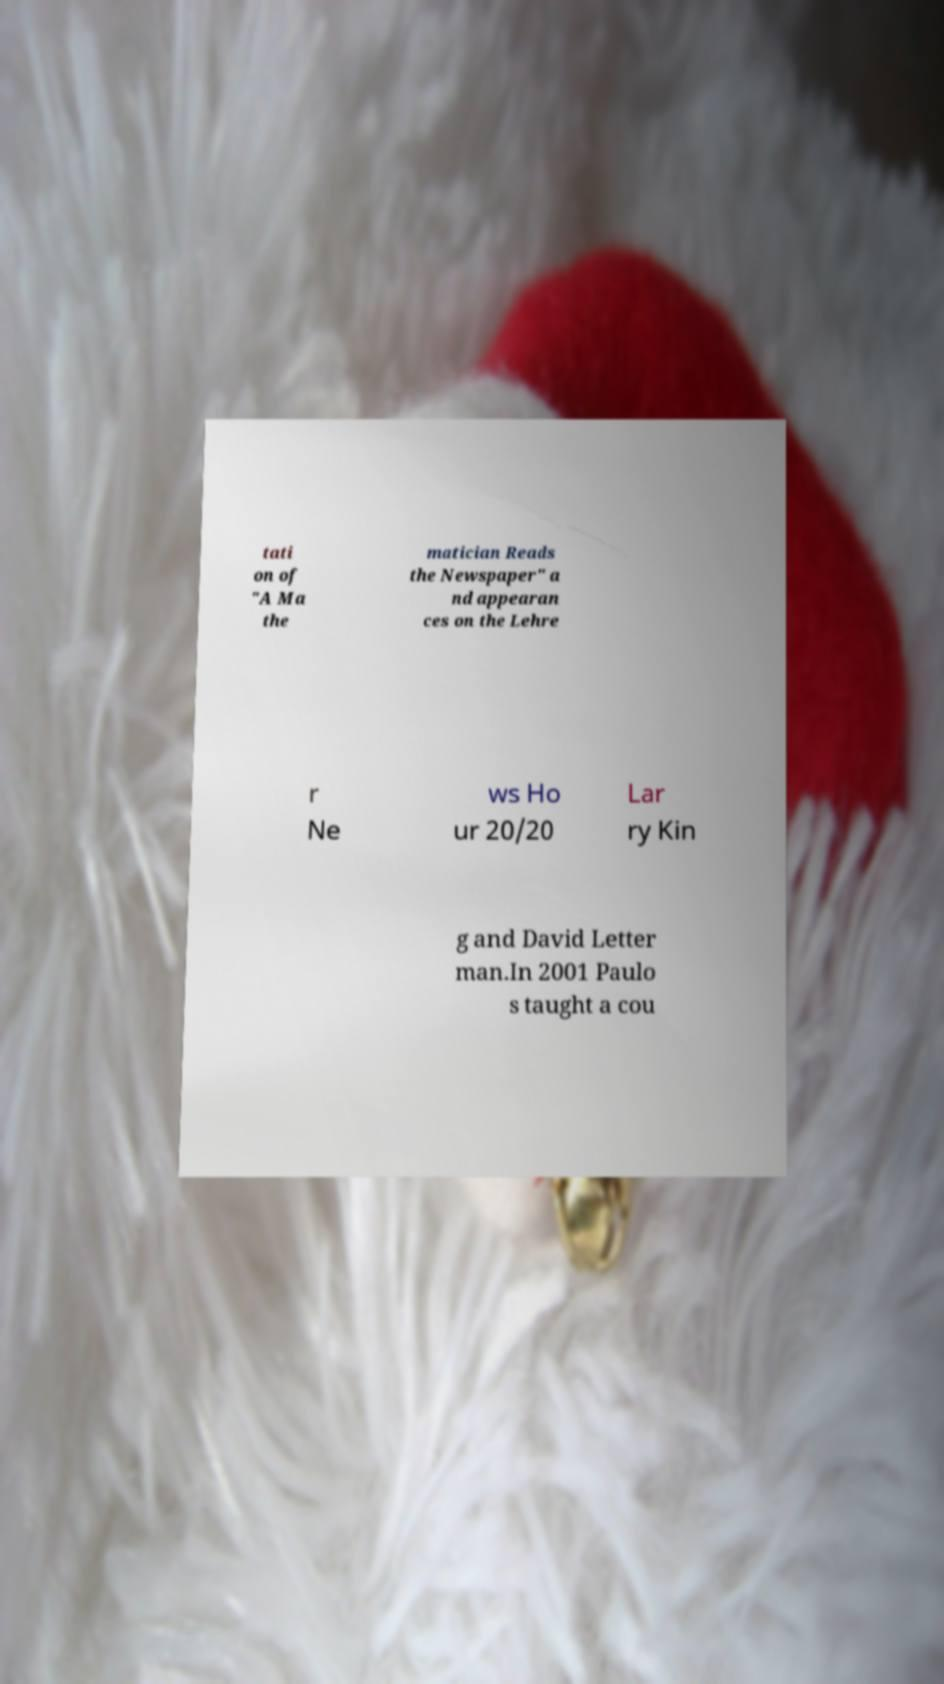Please read and relay the text visible in this image. What does it say? tati on of "A Ma the matician Reads the Newspaper" a nd appearan ces on the Lehre r Ne ws Ho ur 20/20 Lar ry Kin g and David Letter man.In 2001 Paulo s taught a cou 